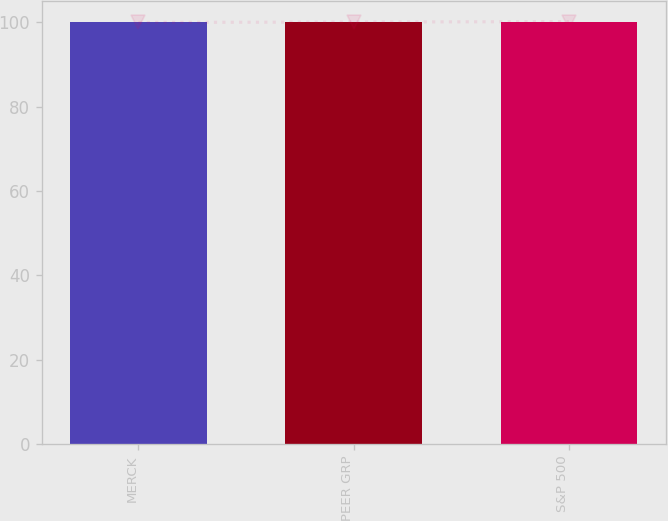<chart> <loc_0><loc_0><loc_500><loc_500><bar_chart><fcel>MERCK<fcel>PEER GRP<fcel>S&P 500<nl><fcel>100<fcel>100.1<fcel>100.2<nl></chart> 